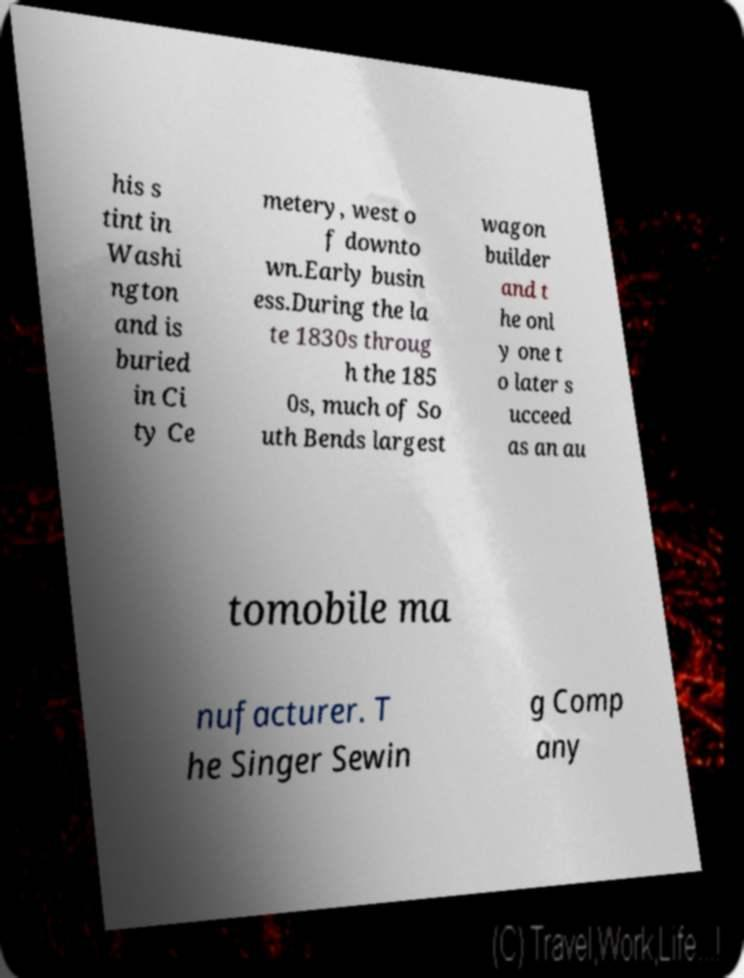Please read and relay the text visible in this image. What does it say? his s tint in Washi ngton and is buried in Ci ty Ce metery, west o f downto wn.Early busin ess.During the la te 1830s throug h the 185 0s, much of So uth Bends largest wagon builder and t he onl y one t o later s ucceed as an au tomobile ma nufacturer. T he Singer Sewin g Comp any 